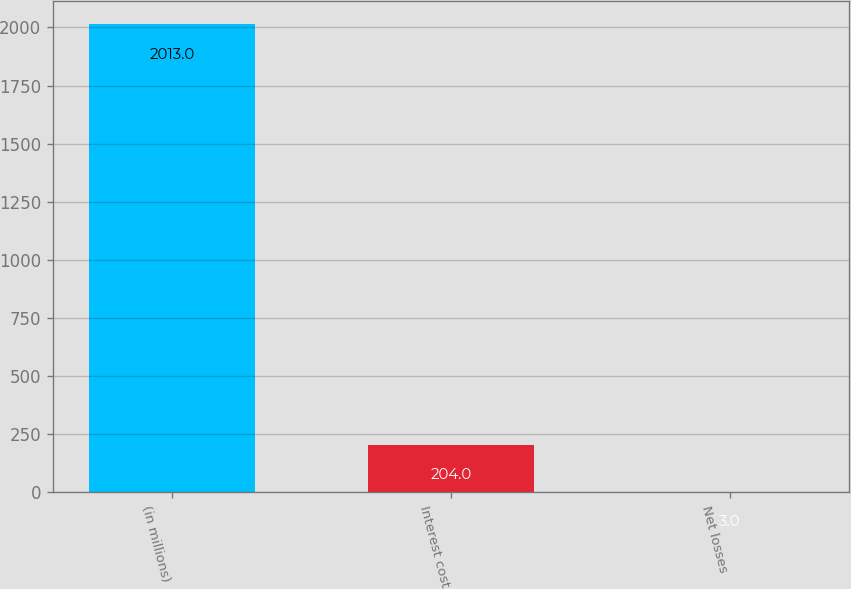Convert chart. <chart><loc_0><loc_0><loc_500><loc_500><bar_chart><fcel>(in millions)<fcel>Interest cost<fcel>Net losses<nl><fcel>2013<fcel>204<fcel>3<nl></chart> 